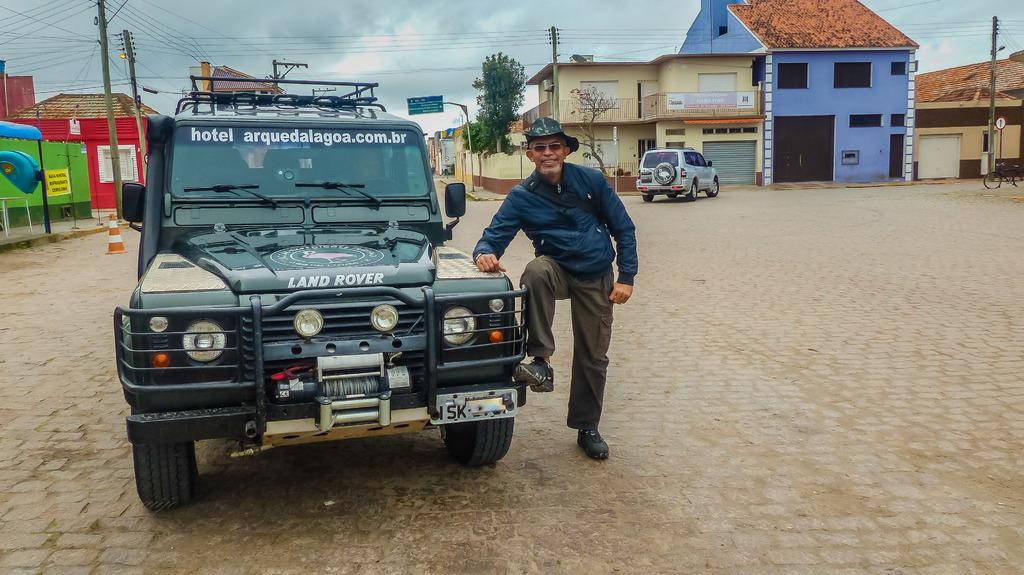What can be seen on the ground in the image? There are vehicles on the ground in the image. Can you describe the person in the image? There is a man in the image. What is visible in the background of the image? There are houses in the background of the image. What type of nut is the man holding in the image? There is no nut present in the image; the man is not holding anything. Is there a doctor in the image? There is no mention of a doctor in the image, and no one is dressed like a doctor. 